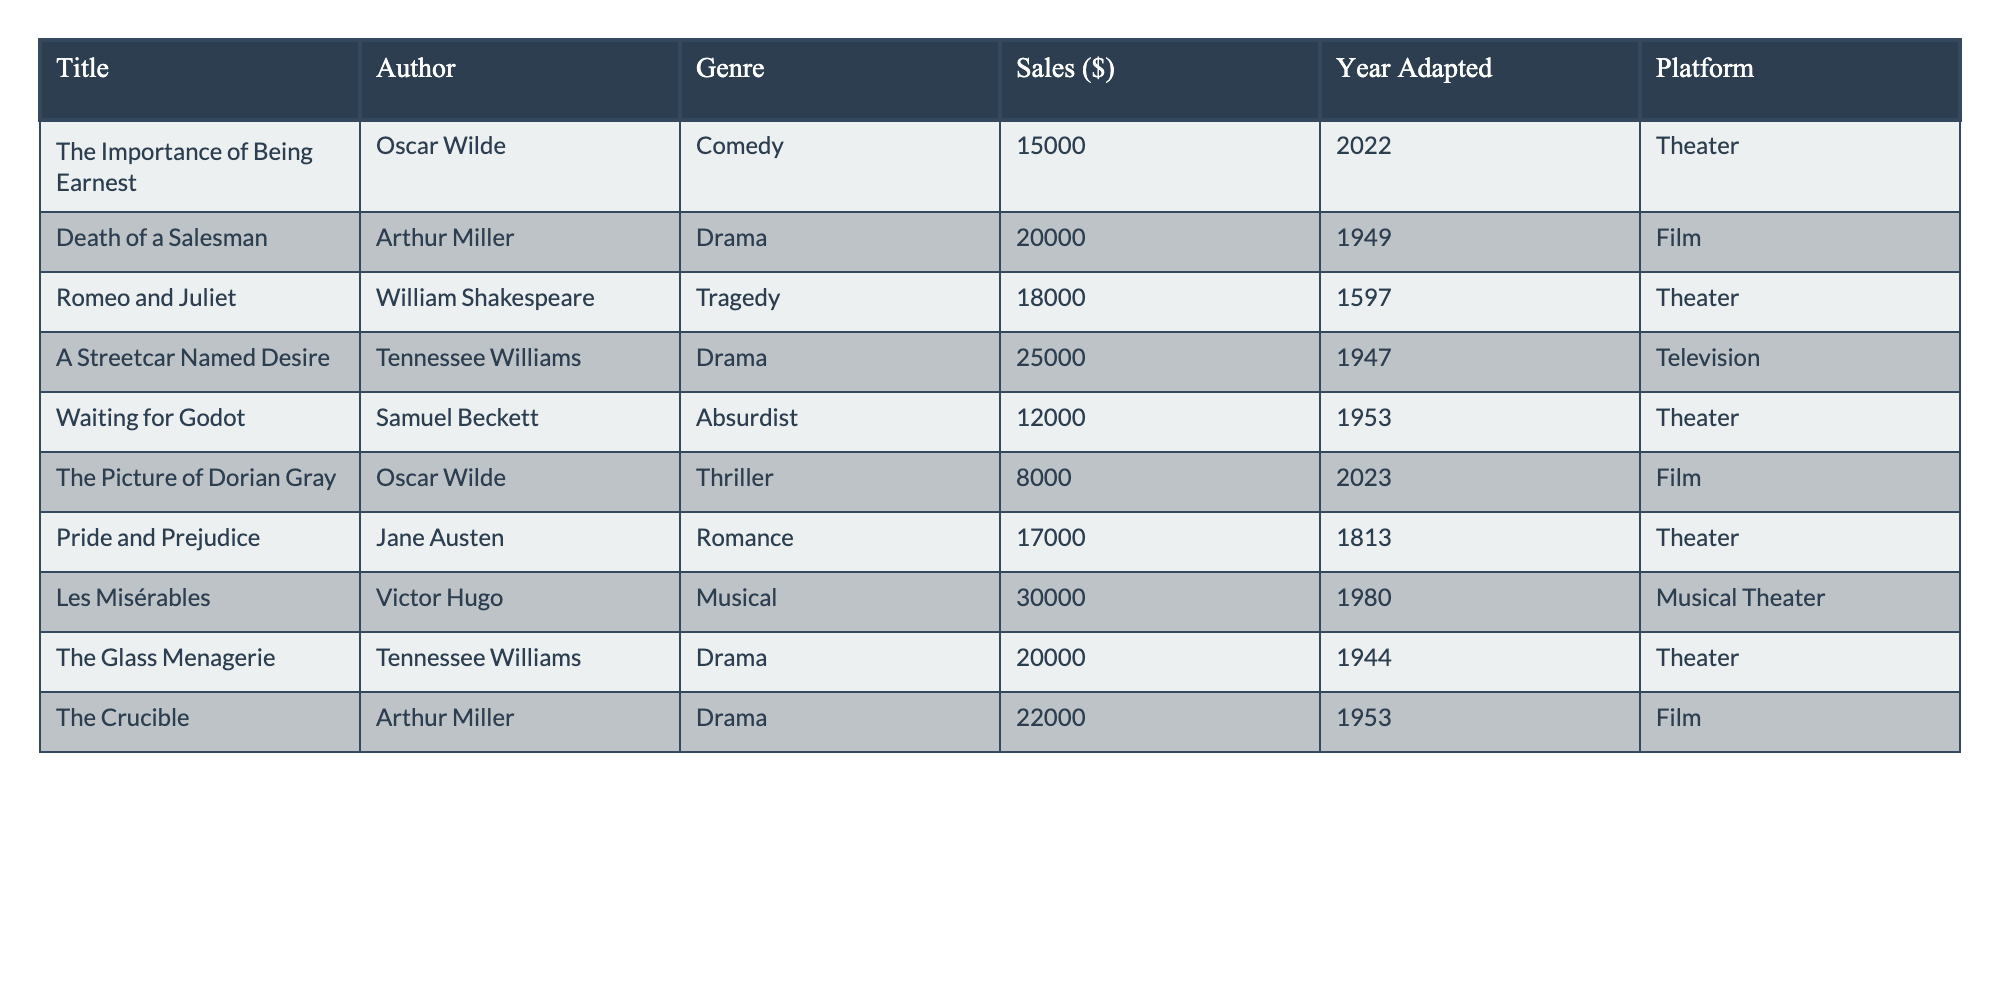What is the total sales amount for all the scripts listed in the table? To find the total sales amount, we sum the sales values for each script: 15000 + 20000 + 18000 + 25000 + 12000 + 8000 + 17000 + 30000 + 20000 + 22000 = 175000
Answer: 175000 Which author has the highest sales listed in the table? The highest sales figure is from "Les Misérables" by Victor Hugo, with sales of 30000, which is greater than any other author's sales.
Answer: Victor Hugo How many theatrical works were adapted into films according to the data? Looking through the table, the works adapted into films are "Death of a Salesman", "The Crucible", and "The Picture of Dorian Gray", totaling three adaptations.
Answer: 3 What is the average sales amount for works adapted into the theater? The theatrical works are "The Importance of Being Earnest", "Romeo and Juliet", "Waiting for Godot", "Pride and Prejudice", "The Glass Menagerie". Their sales are 15000, 18000, 12000, 17000, 20000, which sum to 92000. The average is 92000/5 = 18400.
Answer: 18400 Is "The Picture of Dorian Gray" the most recent adaptation in the table? "The Picture of Dorian Gray" was adapted in 2023, which is later than any other listed adaptations, making it the most recent.
Answer: Yes Which genre has the highest total sales and what is that amount? Summing the sales by genre: Comedy (15000), Drama (20000 + 25000 + 20000 + 22000 = 87000), Tragedy (18000), Absurdist (12000), Thriller (8000), Romance (17000), Musical (30000). The highest is Drama with 87000.
Answer: Drama, 87000 What percentage of total sales does "Les Misérables" contribute? "Les Misérables" sales amount to 30000. The total sales from all entries is 175000. To find the percentage: (30000 / 175000) * 100 = 17.14%.
Answer: 17.14% How many more sales does "A Streetcar Named Desire" have compared to "Waiting for Godot"? "A Streetcar Named Desire" has 25000 in sales and "Waiting for Godot" has 12000. The difference in sales is 25000 - 12000 = 13000.
Answer: 13000 Which adaptation generated the least amount of sales? Looking at the sales figures, "The Picture of Dorian Gray" has the lowest sales at 8000.
Answer: "The Picture of Dorian Gray" Are there any adaptations in the table with sales above 20000? Checking the sales figures, "A Streetcar Named Desire" (25000), "The Crucible" (22000), and "Les Misérables" (30000) all exceed 20000, confirming there are adaptations above this threshold.
Answer: Yes 